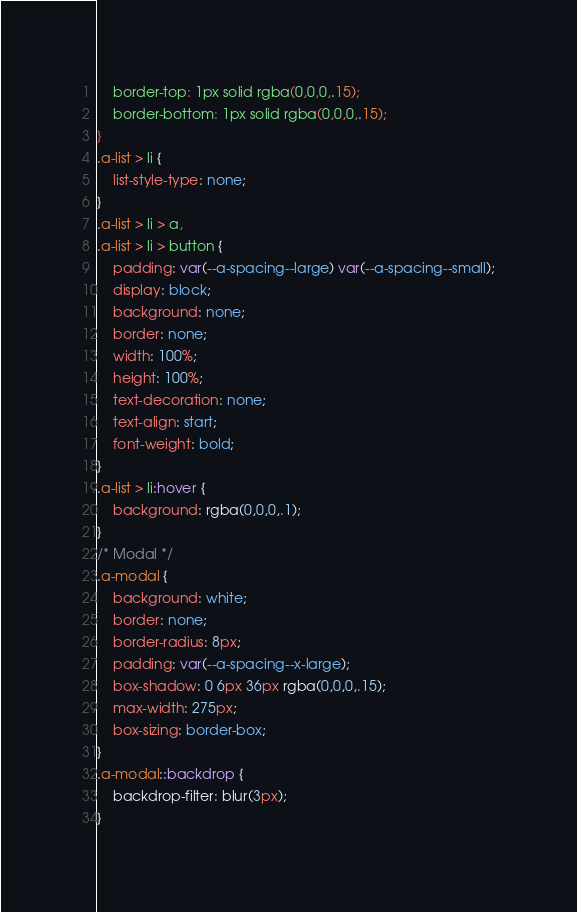Convert code to text. <code><loc_0><loc_0><loc_500><loc_500><_CSS_>    border-top: 1px solid rgba(0,0,0,.15);
    border-bottom: 1px solid rgba(0,0,0,.15);
}
.a-list > li {
    list-style-type: none;
}
.a-list > li > a,
.a-list > li > button {
    padding: var(--a-spacing--large) var(--a-spacing--small);
    display: block;
    background: none;
    border: none;
    width: 100%;
    height: 100%;
    text-decoration: none;
    text-align: start;
    font-weight: bold;
}
.a-list > li:hover {
    background: rgba(0,0,0,.1);
}
/* Modal */
.a-modal {
    background: white;
    border: none;
    border-radius: 8px;
    padding: var(--a-spacing--x-large);
    box-shadow: 0 6px 36px rgba(0,0,0,.15);
    max-width: 275px;
    box-sizing: border-box;
}
.a-modal::backdrop {
    backdrop-filter: blur(3px);
}</code> 